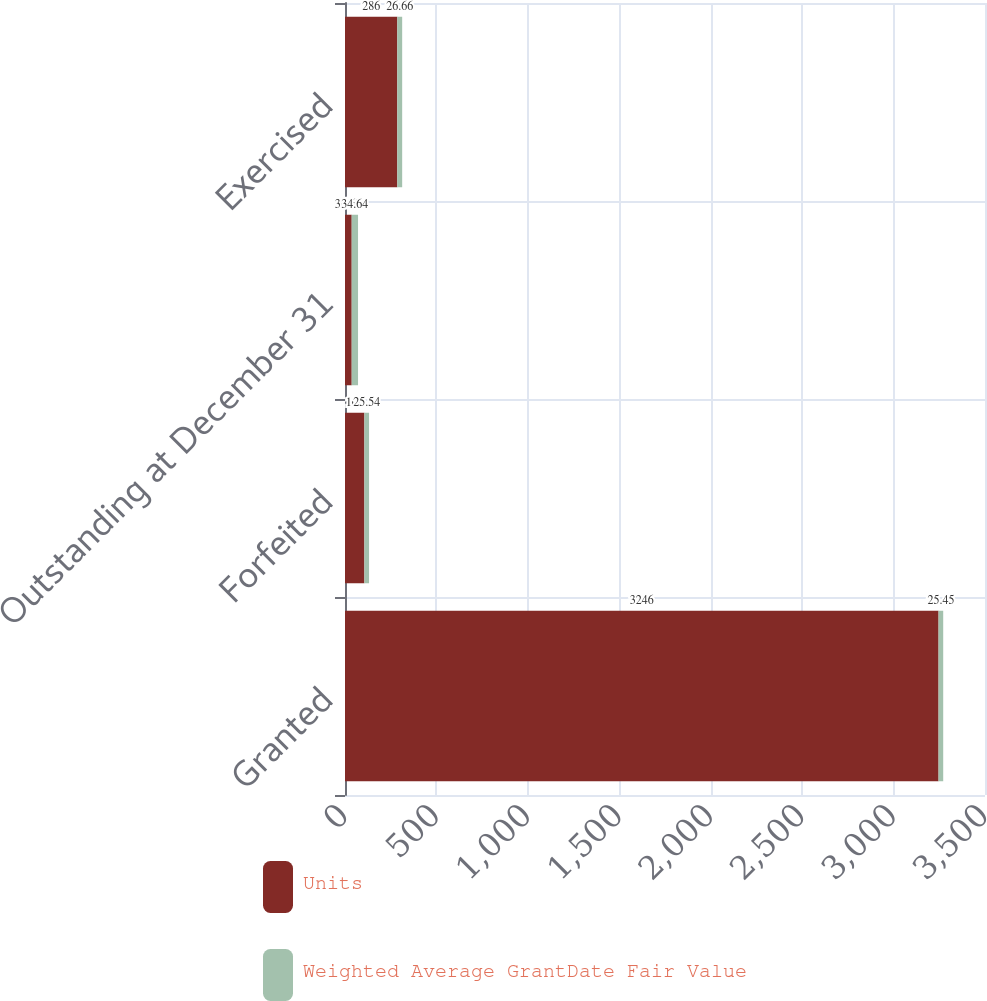<chart> <loc_0><loc_0><loc_500><loc_500><stacked_bar_chart><ecel><fcel>Granted<fcel>Forfeited<fcel>Outstanding at December 31<fcel>Exercised<nl><fcel>Units<fcel>3246<fcel>106<fcel>36.67<fcel>286<nl><fcel>Weighted Average GrantDate Fair Value<fcel>25.45<fcel>25.54<fcel>34.64<fcel>26.66<nl></chart> 